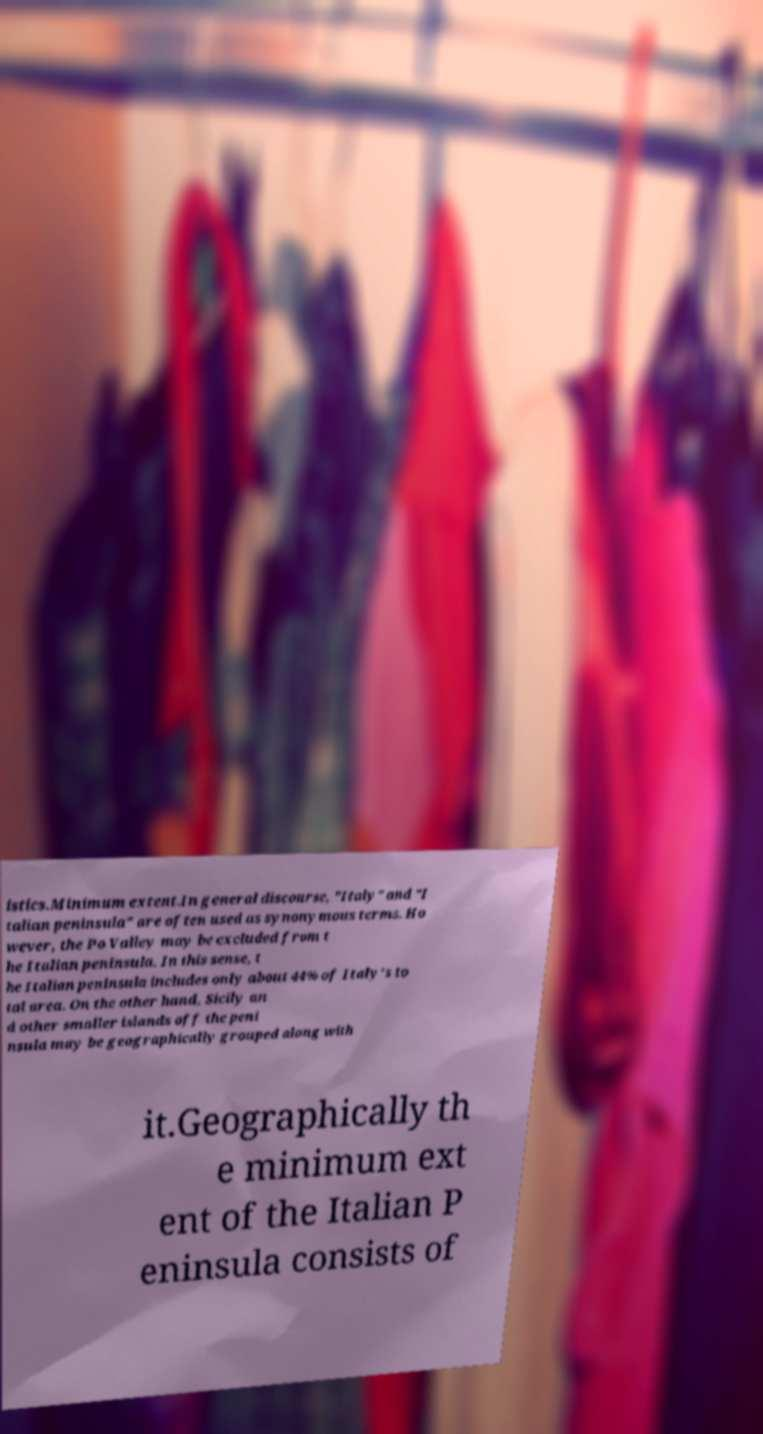What messages or text are displayed in this image? I need them in a readable, typed format. istics.Minimum extent.In general discourse, "Italy" and "I talian peninsula" are often used as synonymous terms. Ho wever, the Po Valley may be excluded from t he Italian peninsula. In this sense, t he Italian peninsula includes only about 44% of Italy's to tal area. On the other hand, Sicily an d other smaller islands off the peni nsula may be geographically grouped along with it.Geographically th e minimum ext ent of the Italian P eninsula consists of 